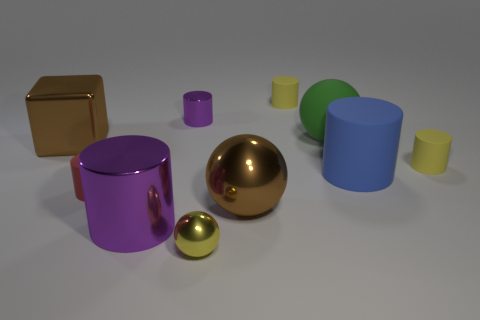What color is the sphere that is right of the tiny matte object that is behind the block?
Offer a very short reply. Green. What is the material of the purple cylinder that is the same size as the metal cube?
Ensure brevity in your answer.  Metal. How many metallic objects are large brown objects or big brown spheres?
Provide a short and direct response. 2. There is a object that is both right of the small purple metallic cylinder and in front of the big brown ball; what color is it?
Your answer should be very brief. Yellow. What number of big blocks are right of the small metallic sphere?
Your response must be concise. 0. What is the material of the tiny red object?
Give a very brief answer. Rubber. What is the color of the rubber cylinder behind the purple metal thing behind the small yellow thing that is right of the blue rubber cylinder?
Your answer should be compact. Yellow. What number of objects are the same size as the block?
Provide a short and direct response. 4. The ball that is in front of the large purple cylinder is what color?
Your answer should be compact. Yellow. How many other objects are the same size as the yellow shiny ball?
Your answer should be compact. 4. 